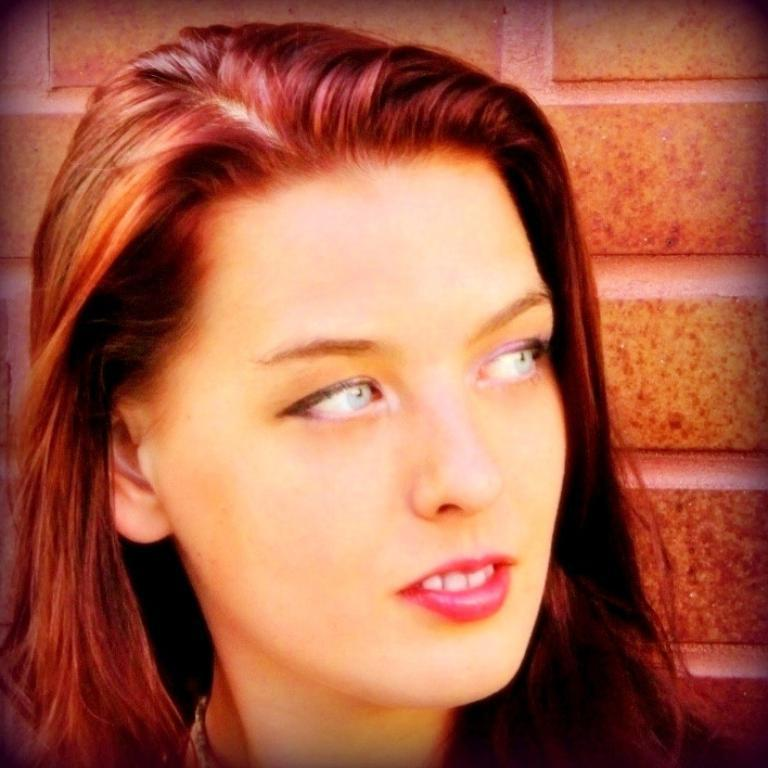Who is present in the image? There is a woman in the image. What is the woman doing in the image? The woman is watching something and smiling. What can be seen in the background of the image? There is a wall in the background of the image. What type of drum is the woman playing in the image? There is no drum present in the image; the woman is watching something and smiling. 